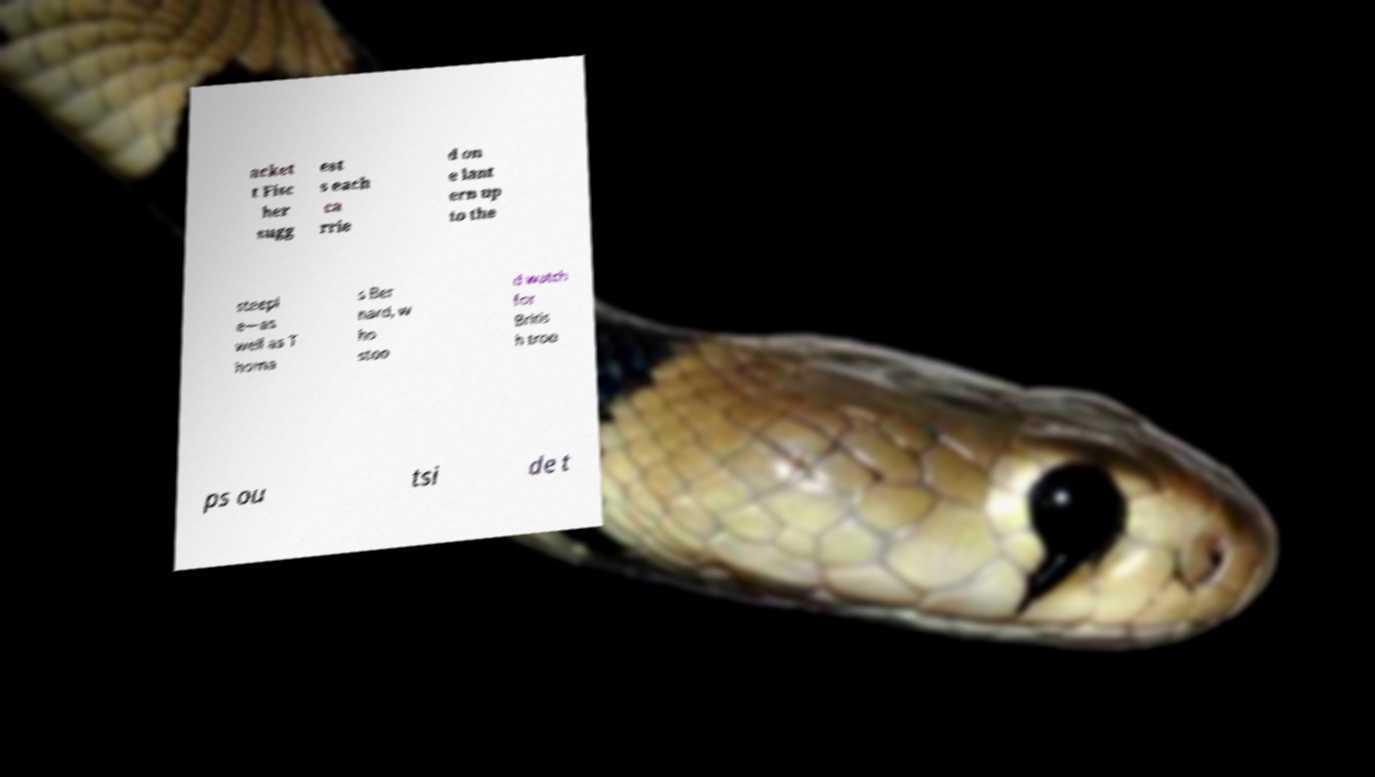There's text embedded in this image that I need extracted. Can you transcribe it verbatim? acket t Fisc her sugg est s each ca rrie d on e lant ern up to the steepl e—as well as T homa s Ber nard, w ho stoo d watch for Britis h troo ps ou tsi de t 